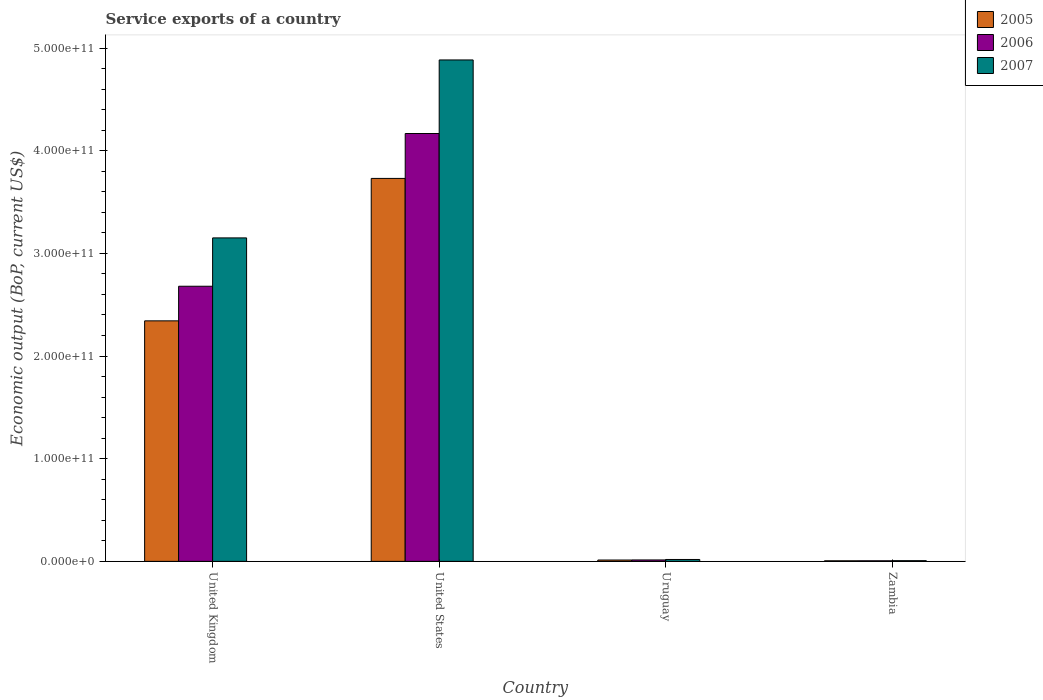Are the number of bars on each tick of the X-axis equal?
Provide a short and direct response. Yes. How many bars are there on the 2nd tick from the right?
Offer a very short reply. 3. What is the label of the 3rd group of bars from the left?
Give a very brief answer. Uruguay. In how many cases, is the number of bars for a given country not equal to the number of legend labels?
Provide a succinct answer. 0. What is the service exports in 2006 in Zambia?
Keep it short and to the point. 5.62e+08. Across all countries, what is the maximum service exports in 2006?
Offer a very short reply. 4.17e+11. Across all countries, what is the minimum service exports in 2006?
Provide a short and direct response. 5.62e+08. In which country was the service exports in 2006 minimum?
Make the answer very short. Zambia. What is the total service exports in 2007 in the graph?
Your answer should be compact. 8.06e+11. What is the difference between the service exports in 2005 in United Kingdom and that in Zambia?
Provide a short and direct response. 2.34e+11. What is the difference between the service exports in 2007 in United Kingdom and the service exports in 2006 in Uruguay?
Your answer should be very brief. 3.14e+11. What is the average service exports in 2007 per country?
Provide a succinct answer. 2.01e+11. What is the difference between the service exports of/in 2007 and service exports of/in 2006 in Zambia?
Offer a very short reply. 1.09e+08. In how many countries, is the service exports in 2005 greater than 160000000000 US$?
Your answer should be compact. 2. What is the ratio of the service exports in 2007 in United States to that in Zambia?
Keep it short and to the point. 727.29. What is the difference between the highest and the second highest service exports in 2006?
Provide a succinct answer. 1.49e+11. What is the difference between the highest and the lowest service exports in 2007?
Provide a succinct answer. 4.88e+11. In how many countries, is the service exports in 2005 greater than the average service exports in 2005 taken over all countries?
Your answer should be very brief. 2. Is the sum of the service exports in 2005 in United States and Uruguay greater than the maximum service exports in 2006 across all countries?
Ensure brevity in your answer.  No. What does the 1st bar from the left in United States represents?
Offer a terse response. 2005. Is it the case that in every country, the sum of the service exports in 2005 and service exports in 2006 is greater than the service exports in 2007?
Provide a succinct answer. Yes. Are all the bars in the graph horizontal?
Your answer should be compact. No. How many countries are there in the graph?
Offer a terse response. 4. What is the difference between two consecutive major ticks on the Y-axis?
Your answer should be compact. 1.00e+11. How many legend labels are there?
Your answer should be compact. 3. What is the title of the graph?
Your response must be concise. Service exports of a country. Does "2015" appear as one of the legend labels in the graph?
Your response must be concise. No. What is the label or title of the Y-axis?
Offer a very short reply. Economic output (BoP, current US$). What is the Economic output (BoP, current US$) of 2005 in United Kingdom?
Keep it short and to the point. 2.34e+11. What is the Economic output (BoP, current US$) in 2006 in United Kingdom?
Keep it short and to the point. 2.68e+11. What is the Economic output (BoP, current US$) of 2007 in United Kingdom?
Offer a terse response. 3.15e+11. What is the Economic output (BoP, current US$) in 2005 in United States?
Ensure brevity in your answer.  3.73e+11. What is the Economic output (BoP, current US$) of 2006 in United States?
Give a very brief answer. 4.17e+11. What is the Economic output (BoP, current US$) in 2007 in United States?
Your answer should be compact. 4.88e+11. What is the Economic output (BoP, current US$) in 2005 in Uruguay?
Offer a terse response. 1.31e+09. What is the Economic output (BoP, current US$) of 2006 in Uruguay?
Make the answer very short. 1.39e+09. What is the Economic output (BoP, current US$) of 2007 in Uruguay?
Keep it short and to the point. 1.83e+09. What is the Economic output (BoP, current US$) in 2005 in Zambia?
Provide a short and direct response. 5.49e+08. What is the Economic output (BoP, current US$) of 2006 in Zambia?
Ensure brevity in your answer.  5.62e+08. What is the Economic output (BoP, current US$) in 2007 in Zambia?
Your answer should be very brief. 6.72e+08. Across all countries, what is the maximum Economic output (BoP, current US$) in 2005?
Offer a terse response. 3.73e+11. Across all countries, what is the maximum Economic output (BoP, current US$) in 2006?
Provide a short and direct response. 4.17e+11. Across all countries, what is the maximum Economic output (BoP, current US$) of 2007?
Offer a terse response. 4.88e+11. Across all countries, what is the minimum Economic output (BoP, current US$) in 2005?
Provide a succinct answer. 5.49e+08. Across all countries, what is the minimum Economic output (BoP, current US$) of 2006?
Provide a succinct answer. 5.62e+08. Across all countries, what is the minimum Economic output (BoP, current US$) of 2007?
Your answer should be very brief. 6.72e+08. What is the total Economic output (BoP, current US$) of 2005 in the graph?
Keep it short and to the point. 6.09e+11. What is the total Economic output (BoP, current US$) of 2006 in the graph?
Ensure brevity in your answer.  6.87e+11. What is the total Economic output (BoP, current US$) in 2007 in the graph?
Offer a terse response. 8.06e+11. What is the difference between the Economic output (BoP, current US$) in 2005 in United Kingdom and that in United States?
Offer a very short reply. -1.39e+11. What is the difference between the Economic output (BoP, current US$) of 2006 in United Kingdom and that in United States?
Provide a short and direct response. -1.49e+11. What is the difference between the Economic output (BoP, current US$) of 2007 in United Kingdom and that in United States?
Provide a short and direct response. -1.73e+11. What is the difference between the Economic output (BoP, current US$) in 2005 in United Kingdom and that in Uruguay?
Ensure brevity in your answer.  2.33e+11. What is the difference between the Economic output (BoP, current US$) in 2006 in United Kingdom and that in Uruguay?
Your response must be concise. 2.67e+11. What is the difference between the Economic output (BoP, current US$) in 2007 in United Kingdom and that in Uruguay?
Keep it short and to the point. 3.13e+11. What is the difference between the Economic output (BoP, current US$) of 2005 in United Kingdom and that in Zambia?
Offer a very short reply. 2.34e+11. What is the difference between the Economic output (BoP, current US$) of 2006 in United Kingdom and that in Zambia?
Your answer should be very brief. 2.67e+11. What is the difference between the Economic output (BoP, current US$) of 2007 in United Kingdom and that in Zambia?
Your answer should be very brief. 3.14e+11. What is the difference between the Economic output (BoP, current US$) in 2005 in United States and that in Uruguay?
Keep it short and to the point. 3.72e+11. What is the difference between the Economic output (BoP, current US$) in 2006 in United States and that in Uruguay?
Your answer should be compact. 4.15e+11. What is the difference between the Economic output (BoP, current US$) of 2007 in United States and that in Uruguay?
Keep it short and to the point. 4.87e+11. What is the difference between the Economic output (BoP, current US$) of 2005 in United States and that in Zambia?
Keep it short and to the point. 3.72e+11. What is the difference between the Economic output (BoP, current US$) in 2006 in United States and that in Zambia?
Provide a succinct answer. 4.16e+11. What is the difference between the Economic output (BoP, current US$) in 2007 in United States and that in Zambia?
Give a very brief answer. 4.88e+11. What is the difference between the Economic output (BoP, current US$) in 2005 in Uruguay and that in Zambia?
Your answer should be compact. 7.62e+08. What is the difference between the Economic output (BoP, current US$) of 2006 in Uruguay and that in Zambia?
Provide a succinct answer. 8.25e+08. What is the difference between the Economic output (BoP, current US$) in 2007 in Uruguay and that in Zambia?
Your answer should be compact. 1.16e+09. What is the difference between the Economic output (BoP, current US$) of 2005 in United Kingdom and the Economic output (BoP, current US$) of 2006 in United States?
Give a very brief answer. -1.82e+11. What is the difference between the Economic output (BoP, current US$) of 2005 in United Kingdom and the Economic output (BoP, current US$) of 2007 in United States?
Make the answer very short. -2.54e+11. What is the difference between the Economic output (BoP, current US$) of 2006 in United Kingdom and the Economic output (BoP, current US$) of 2007 in United States?
Your answer should be very brief. -2.20e+11. What is the difference between the Economic output (BoP, current US$) of 2005 in United Kingdom and the Economic output (BoP, current US$) of 2006 in Uruguay?
Your answer should be compact. 2.33e+11. What is the difference between the Economic output (BoP, current US$) of 2005 in United Kingdom and the Economic output (BoP, current US$) of 2007 in Uruguay?
Your answer should be very brief. 2.32e+11. What is the difference between the Economic output (BoP, current US$) in 2006 in United Kingdom and the Economic output (BoP, current US$) in 2007 in Uruguay?
Ensure brevity in your answer.  2.66e+11. What is the difference between the Economic output (BoP, current US$) of 2005 in United Kingdom and the Economic output (BoP, current US$) of 2006 in Zambia?
Provide a succinct answer. 2.34e+11. What is the difference between the Economic output (BoP, current US$) of 2005 in United Kingdom and the Economic output (BoP, current US$) of 2007 in Zambia?
Keep it short and to the point. 2.34e+11. What is the difference between the Economic output (BoP, current US$) in 2006 in United Kingdom and the Economic output (BoP, current US$) in 2007 in Zambia?
Give a very brief answer. 2.67e+11. What is the difference between the Economic output (BoP, current US$) in 2005 in United States and the Economic output (BoP, current US$) in 2006 in Uruguay?
Keep it short and to the point. 3.72e+11. What is the difference between the Economic output (BoP, current US$) of 2005 in United States and the Economic output (BoP, current US$) of 2007 in Uruguay?
Keep it short and to the point. 3.71e+11. What is the difference between the Economic output (BoP, current US$) of 2006 in United States and the Economic output (BoP, current US$) of 2007 in Uruguay?
Ensure brevity in your answer.  4.15e+11. What is the difference between the Economic output (BoP, current US$) in 2005 in United States and the Economic output (BoP, current US$) in 2006 in Zambia?
Make the answer very short. 3.72e+11. What is the difference between the Economic output (BoP, current US$) in 2005 in United States and the Economic output (BoP, current US$) in 2007 in Zambia?
Ensure brevity in your answer.  3.72e+11. What is the difference between the Economic output (BoP, current US$) in 2006 in United States and the Economic output (BoP, current US$) in 2007 in Zambia?
Keep it short and to the point. 4.16e+11. What is the difference between the Economic output (BoP, current US$) in 2005 in Uruguay and the Economic output (BoP, current US$) in 2006 in Zambia?
Provide a succinct answer. 7.49e+08. What is the difference between the Economic output (BoP, current US$) of 2005 in Uruguay and the Economic output (BoP, current US$) of 2007 in Zambia?
Your answer should be very brief. 6.40e+08. What is the difference between the Economic output (BoP, current US$) of 2006 in Uruguay and the Economic output (BoP, current US$) of 2007 in Zambia?
Your response must be concise. 7.16e+08. What is the average Economic output (BoP, current US$) in 2005 per country?
Offer a terse response. 1.52e+11. What is the average Economic output (BoP, current US$) of 2006 per country?
Provide a short and direct response. 1.72e+11. What is the average Economic output (BoP, current US$) in 2007 per country?
Ensure brevity in your answer.  2.01e+11. What is the difference between the Economic output (BoP, current US$) in 2005 and Economic output (BoP, current US$) in 2006 in United Kingdom?
Keep it short and to the point. -3.37e+1. What is the difference between the Economic output (BoP, current US$) of 2005 and Economic output (BoP, current US$) of 2007 in United Kingdom?
Provide a short and direct response. -8.08e+1. What is the difference between the Economic output (BoP, current US$) in 2006 and Economic output (BoP, current US$) in 2007 in United Kingdom?
Provide a short and direct response. -4.71e+1. What is the difference between the Economic output (BoP, current US$) of 2005 and Economic output (BoP, current US$) of 2006 in United States?
Provide a succinct answer. -4.37e+1. What is the difference between the Economic output (BoP, current US$) in 2005 and Economic output (BoP, current US$) in 2007 in United States?
Make the answer very short. -1.15e+11. What is the difference between the Economic output (BoP, current US$) of 2006 and Economic output (BoP, current US$) of 2007 in United States?
Provide a short and direct response. -7.17e+1. What is the difference between the Economic output (BoP, current US$) of 2005 and Economic output (BoP, current US$) of 2006 in Uruguay?
Ensure brevity in your answer.  -7.61e+07. What is the difference between the Economic output (BoP, current US$) in 2005 and Economic output (BoP, current US$) in 2007 in Uruguay?
Provide a short and direct response. -5.22e+08. What is the difference between the Economic output (BoP, current US$) in 2006 and Economic output (BoP, current US$) in 2007 in Uruguay?
Your answer should be very brief. -4.46e+08. What is the difference between the Economic output (BoP, current US$) of 2005 and Economic output (BoP, current US$) of 2006 in Zambia?
Provide a succinct answer. -1.28e+07. What is the difference between the Economic output (BoP, current US$) of 2005 and Economic output (BoP, current US$) of 2007 in Zambia?
Offer a terse response. -1.22e+08. What is the difference between the Economic output (BoP, current US$) in 2006 and Economic output (BoP, current US$) in 2007 in Zambia?
Your response must be concise. -1.09e+08. What is the ratio of the Economic output (BoP, current US$) of 2005 in United Kingdom to that in United States?
Offer a terse response. 0.63. What is the ratio of the Economic output (BoP, current US$) of 2006 in United Kingdom to that in United States?
Your answer should be very brief. 0.64. What is the ratio of the Economic output (BoP, current US$) of 2007 in United Kingdom to that in United States?
Ensure brevity in your answer.  0.65. What is the ratio of the Economic output (BoP, current US$) in 2005 in United Kingdom to that in Uruguay?
Offer a very short reply. 178.65. What is the ratio of the Economic output (BoP, current US$) of 2006 in United Kingdom to that in Uruguay?
Make the answer very short. 193.14. What is the ratio of the Economic output (BoP, current US$) of 2007 in United Kingdom to that in Uruguay?
Your response must be concise. 171.84. What is the ratio of the Economic output (BoP, current US$) in 2005 in United Kingdom to that in Zambia?
Offer a terse response. 426.34. What is the ratio of the Economic output (BoP, current US$) of 2006 in United Kingdom to that in Zambia?
Make the answer very short. 476.58. What is the ratio of the Economic output (BoP, current US$) in 2007 in United Kingdom to that in Zambia?
Your answer should be very brief. 469.17. What is the ratio of the Economic output (BoP, current US$) in 2005 in United States to that in Uruguay?
Your answer should be very brief. 284.46. What is the ratio of the Economic output (BoP, current US$) in 2006 in United States to that in Uruguay?
Ensure brevity in your answer.  300.37. What is the ratio of the Economic output (BoP, current US$) in 2007 in United States to that in Uruguay?
Keep it short and to the point. 266.38. What is the ratio of the Economic output (BoP, current US$) in 2005 in United States to that in Zambia?
Offer a terse response. 678.85. What is the ratio of the Economic output (BoP, current US$) in 2006 in United States to that in Zambia?
Provide a succinct answer. 741.16. What is the ratio of the Economic output (BoP, current US$) of 2007 in United States to that in Zambia?
Give a very brief answer. 727.29. What is the ratio of the Economic output (BoP, current US$) in 2005 in Uruguay to that in Zambia?
Provide a short and direct response. 2.39. What is the ratio of the Economic output (BoP, current US$) of 2006 in Uruguay to that in Zambia?
Make the answer very short. 2.47. What is the ratio of the Economic output (BoP, current US$) in 2007 in Uruguay to that in Zambia?
Ensure brevity in your answer.  2.73. What is the difference between the highest and the second highest Economic output (BoP, current US$) of 2005?
Offer a terse response. 1.39e+11. What is the difference between the highest and the second highest Economic output (BoP, current US$) of 2006?
Your answer should be compact. 1.49e+11. What is the difference between the highest and the second highest Economic output (BoP, current US$) in 2007?
Offer a terse response. 1.73e+11. What is the difference between the highest and the lowest Economic output (BoP, current US$) in 2005?
Your response must be concise. 3.72e+11. What is the difference between the highest and the lowest Economic output (BoP, current US$) in 2006?
Keep it short and to the point. 4.16e+11. What is the difference between the highest and the lowest Economic output (BoP, current US$) in 2007?
Offer a terse response. 4.88e+11. 